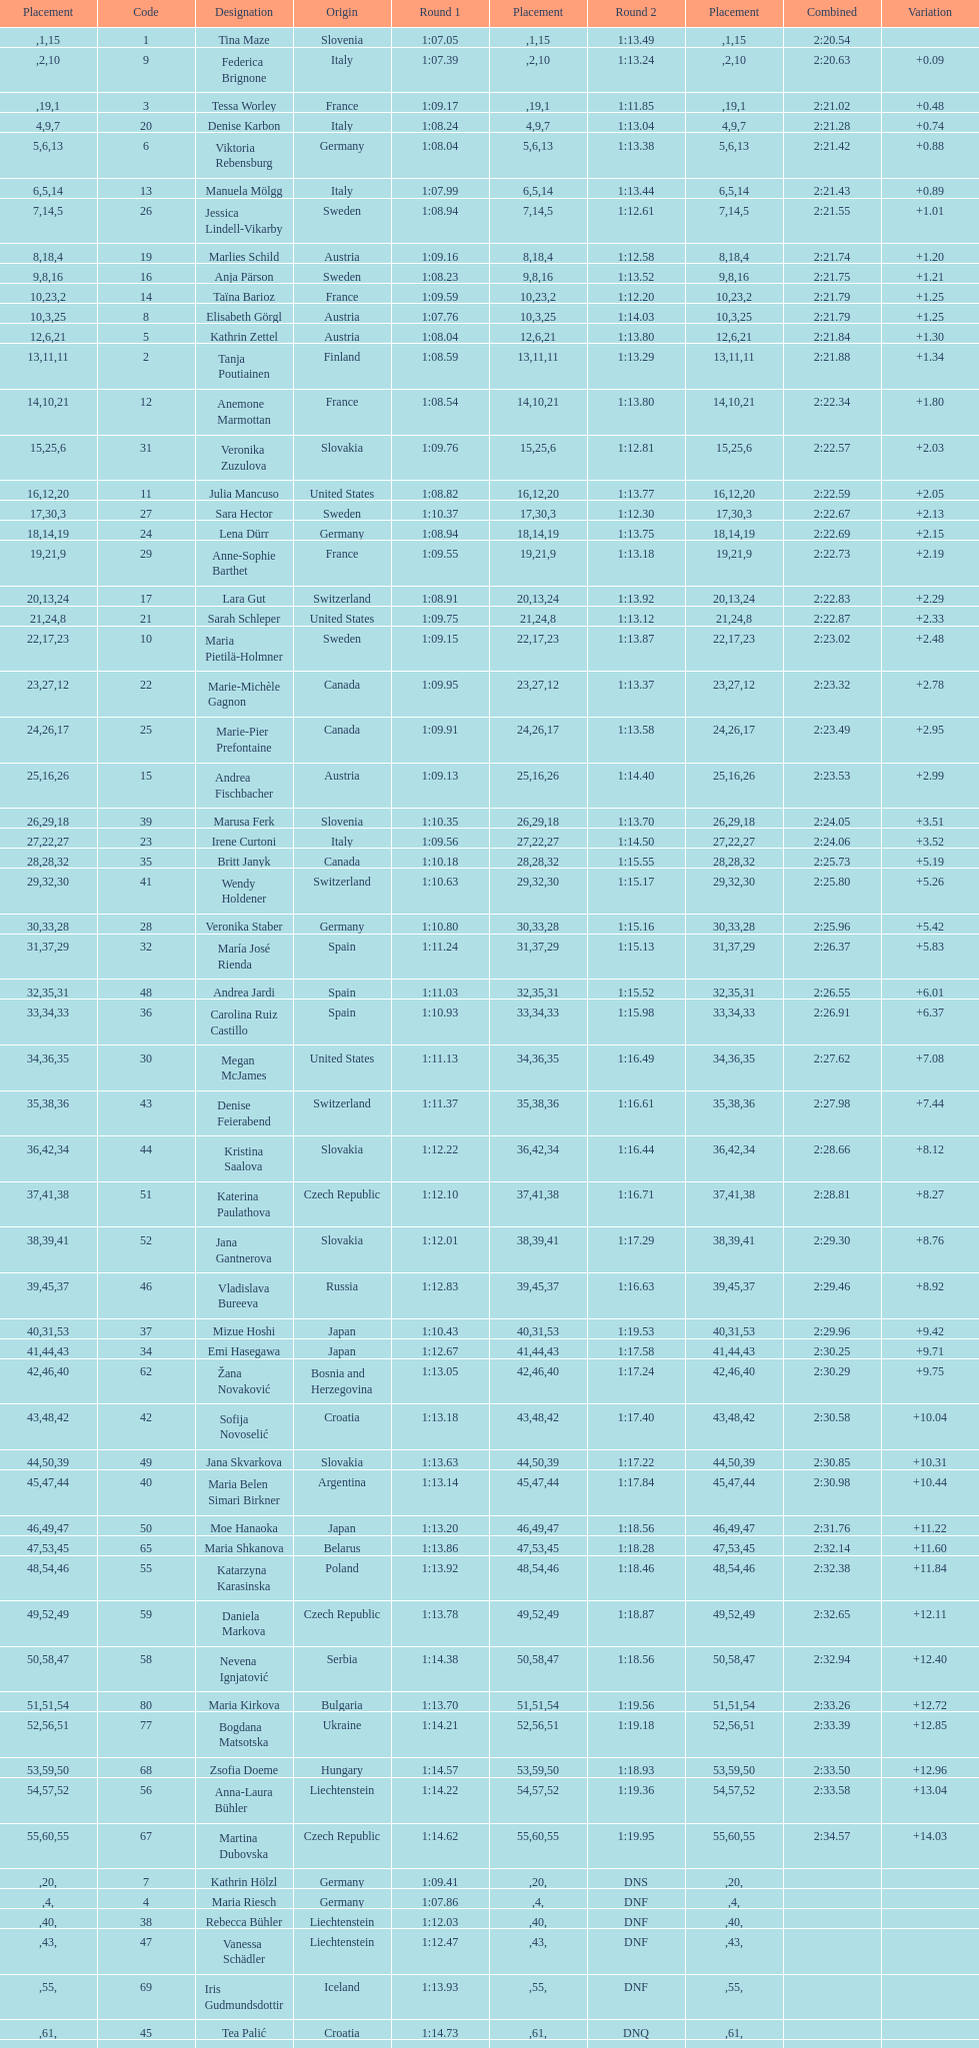How long did it take tina maze to finish the race? 2:20.54. 